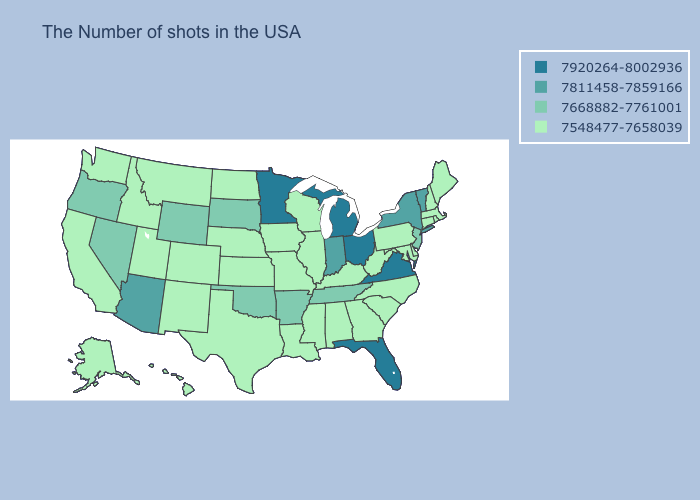Which states have the highest value in the USA?
Quick response, please. Virginia, Ohio, Florida, Michigan, Minnesota. Does Arizona have the highest value in the West?
Write a very short answer. Yes. What is the lowest value in the MidWest?
Concise answer only. 7548477-7658039. Does the map have missing data?
Give a very brief answer. No. Which states have the lowest value in the MidWest?
Give a very brief answer. Wisconsin, Illinois, Missouri, Iowa, Kansas, Nebraska, North Dakota. Which states have the highest value in the USA?
Quick response, please. Virginia, Ohio, Florida, Michigan, Minnesota. Among the states that border Colorado , which have the lowest value?
Write a very short answer. Kansas, Nebraska, New Mexico, Utah. Does Arkansas have the lowest value in the USA?
Answer briefly. No. Name the states that have a value in the range 7668882-7761001?
Keep it brief. New Jersey, Tennessee, Arkansas, Oklahoma, South Dakota, Wyoming, Nevada, Oregon. Name the states that have a value in the range 7668882-7761001?
Give a very brief answer. New Jersey, Tennessee, Arkansas, Oklahoma, South Dakota, Wyoming, Nevada, Oregon. What is the highest value in the USA?
Answer briefly. 7920264-8002936. Does Rhode Island have a lower value than Maine?
Quick response, please. No. What is the value of North Carolina?
Answer briefly. 7548477-7658039. Name the states that have a value in the range 7668882-7761001?
Concise answer only. New Jersey, Tennessee, Arkansas, Oklahoma, South Dakota, Wyoming, Nevada, Oregon. Among the states that border Arkansas , does Mississippi have the highest value?
Keep it brief. No. 